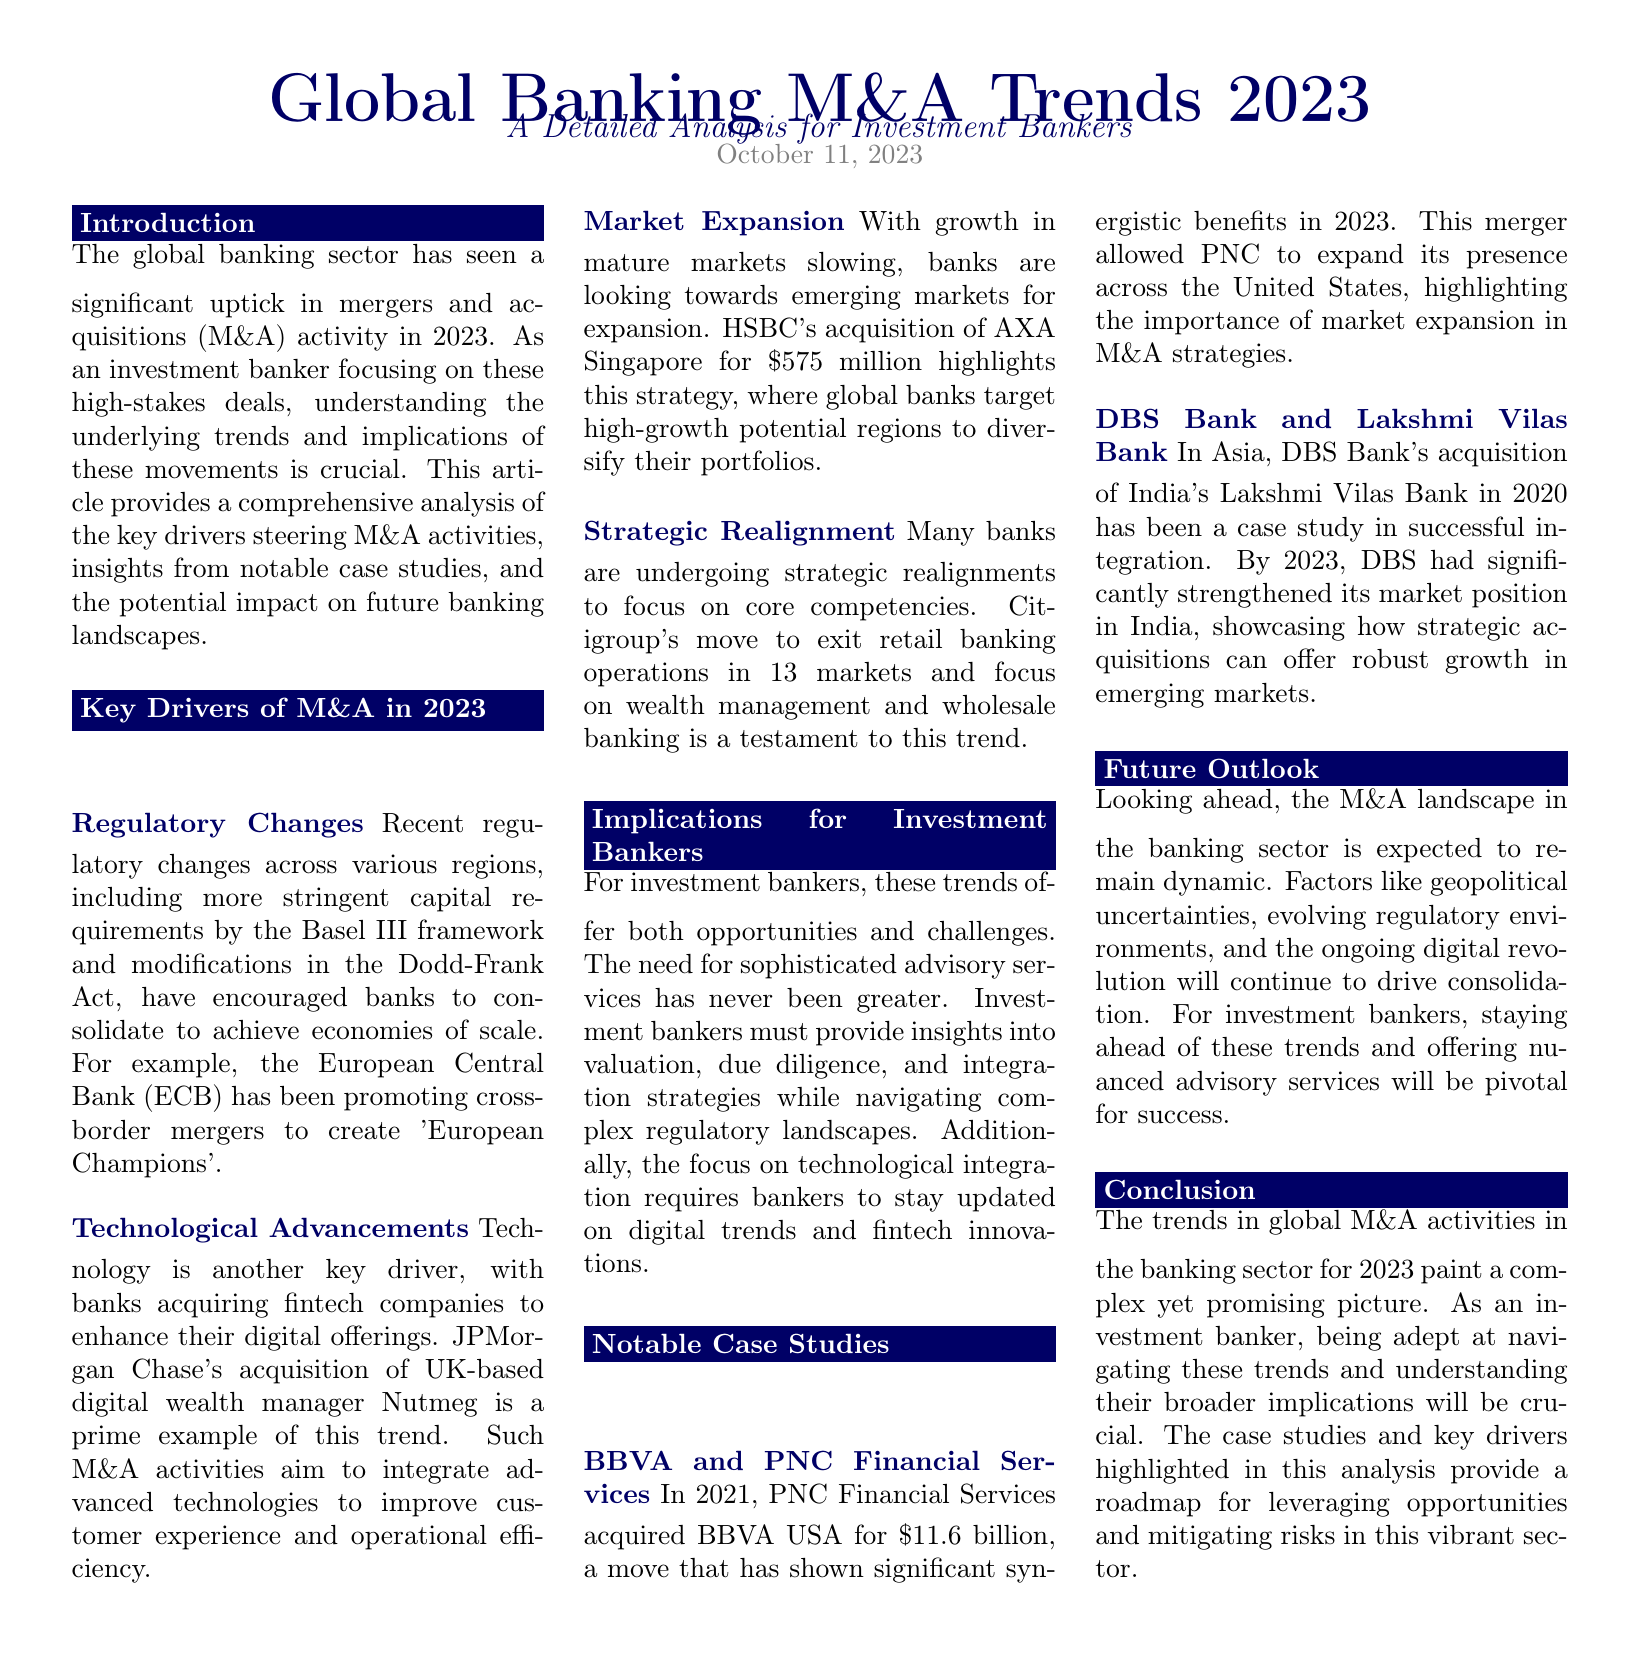What significant trend in 2023 does the document discuss? The document discusses a significant uptick in mergers and acquisitions (M&A) activity in the banking sector in 2023.
Answer: M&A activity What example of a bank acquisition is mentioned related to regulatory changes? The document cites JPMorgan Chase's acquisition of UK-based digital wealth manager Nutmeg as an example related to technological advancements.
Answer: Nutmeg How much did HSBC pay for AXA Singapore? The document states that HSBC's acquisition of AXA Singapore was for $575 million.
Answer: $575 million Which regulatory framework is mentioned as promoting bank consolidation? The Basel III framework is stated as encouraging banks to consolidate for economies of scale.
Answer: Basel III What is Citigroup shifting focus toward? The document highlights Citigroup's move to focus on wealth management and wholesale banking.
Answer: Wealth management and wholesale banking What is the key challenge for investment bankers highlighted in the document? The document indicates that the need for sophisticated advisory services is a key challenge for investment bankers.
Answer: Sophisticated advisory services In what year did PNC Financial Services acquire BBVA USA? The document mentions that PNC Financial Services acquired BBVA USA in 2021.
Answer: 2021 What major factor is driving M&A consolidation according to the future outlook? The document suggests that geopolitical uncertainties are a major factor driving M&A consolidation.
Answer: Geopolitical uncertainties What case study is provided for successful integration? The document references DBS Bank's acquisition of India's Lakshmi Vilas Bank as a case study for successful integration.
Answer: Lakshmi Vilas Bank 